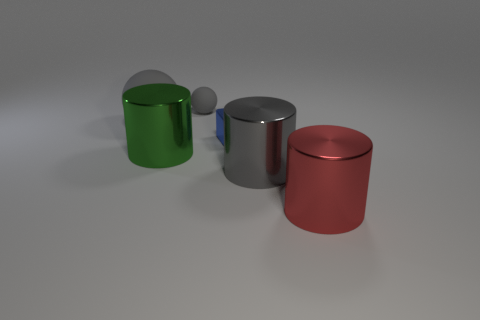Subtract all large green cylinders. How many cylinders are left? 2 Add 2 big yellow metal balls. How many objects exist? 8 Subtract all balls. How many objects are left? 4 Subtract all blue cylinders. Subtract all blue spheres. How many cylinders are left? 3 Add 2 large rubber objects. How many large rubber objects are left? 3 Add 1 matte things. How many matte things exist? 3 Subtract 0 cyan cylinders. How many objects are left? 6 Subtract all big gray matte objects. Subtract all large gray balls. How many objects are left? 4 